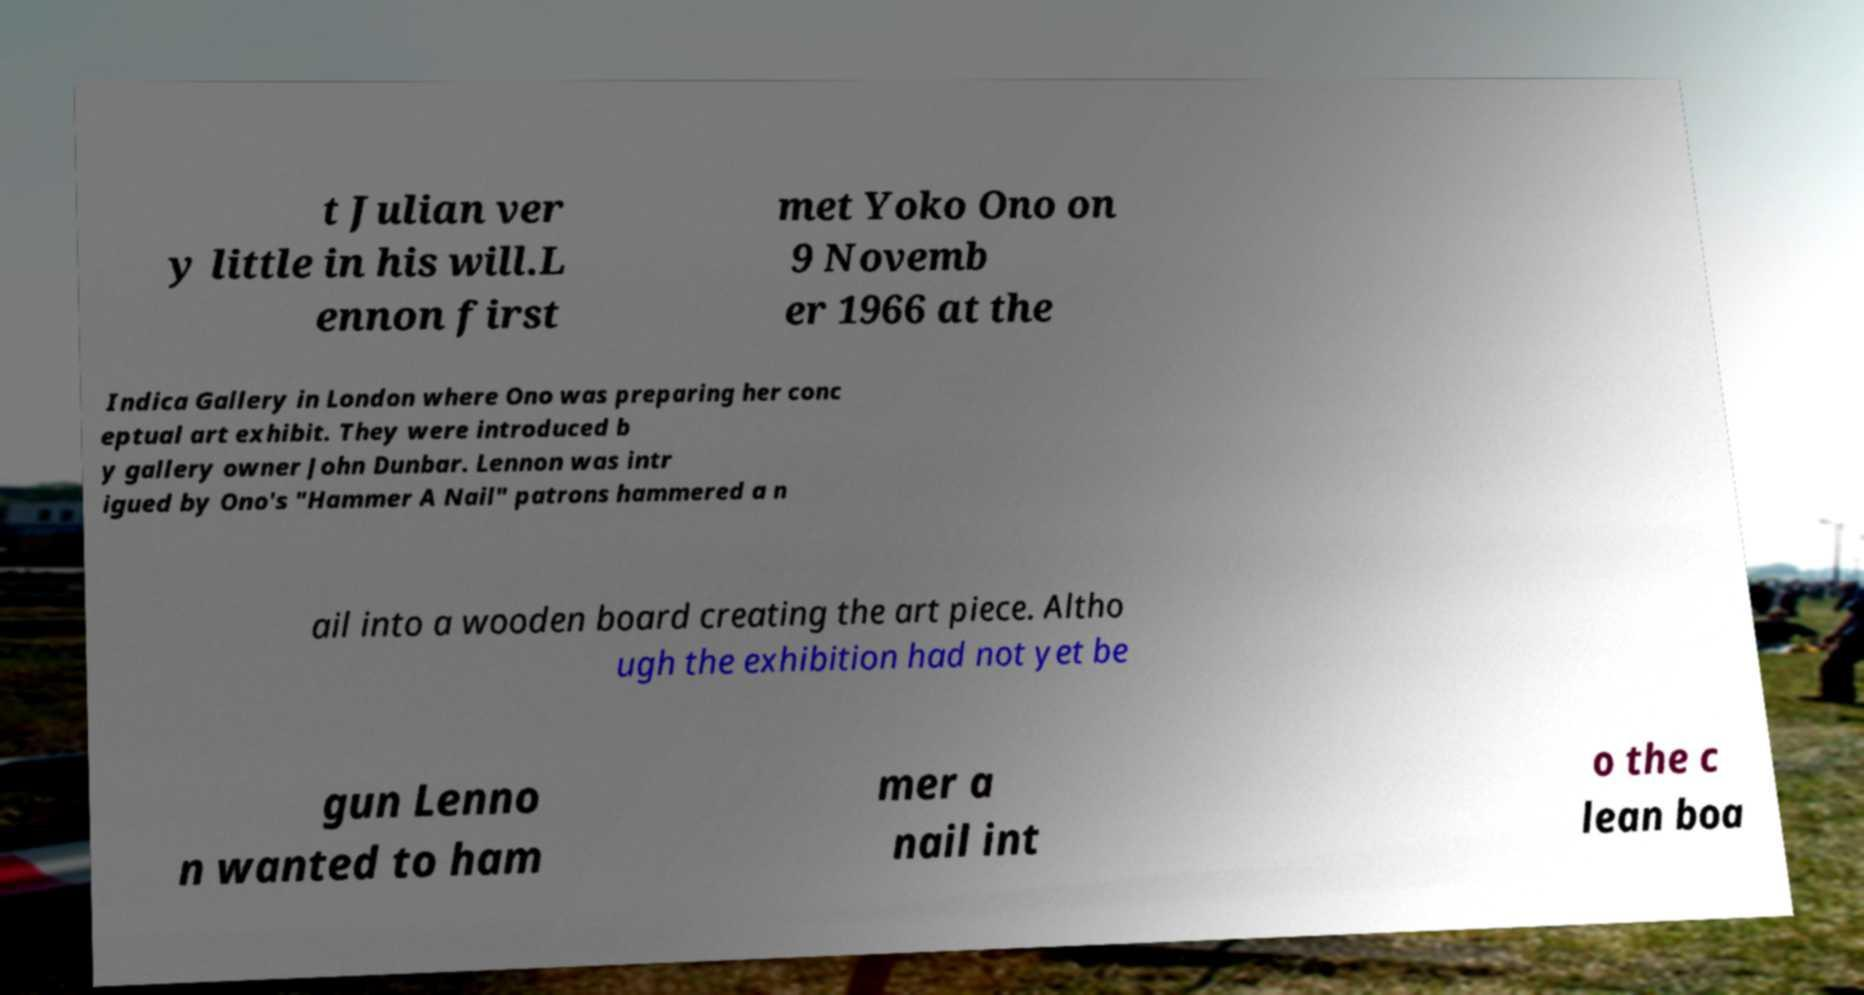Can you accurately transcribe the text from the provided image for me? t Julian ver y little in his will.L ennon first met Yoko Ono on 9 Novemb er 1966 at the Indica Gallery in London where Ono was preparing her conc eptual art exhibit. They were introduced b y gallery owner John Dunbar. Lennon was intr igued by Ono's "Hammer A Nail" patrons hammered a n ail into a wooden board creating the art piece. Altho ugh the exhibition had not yet be gun Lenno n wanted to ham mer a nail int o the c lean boa 